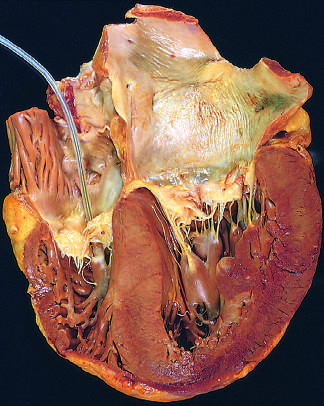what is causing reduction in lumen size?
Answer the question using a single word or phrase. Concentric thickening of the left ventricular wall 